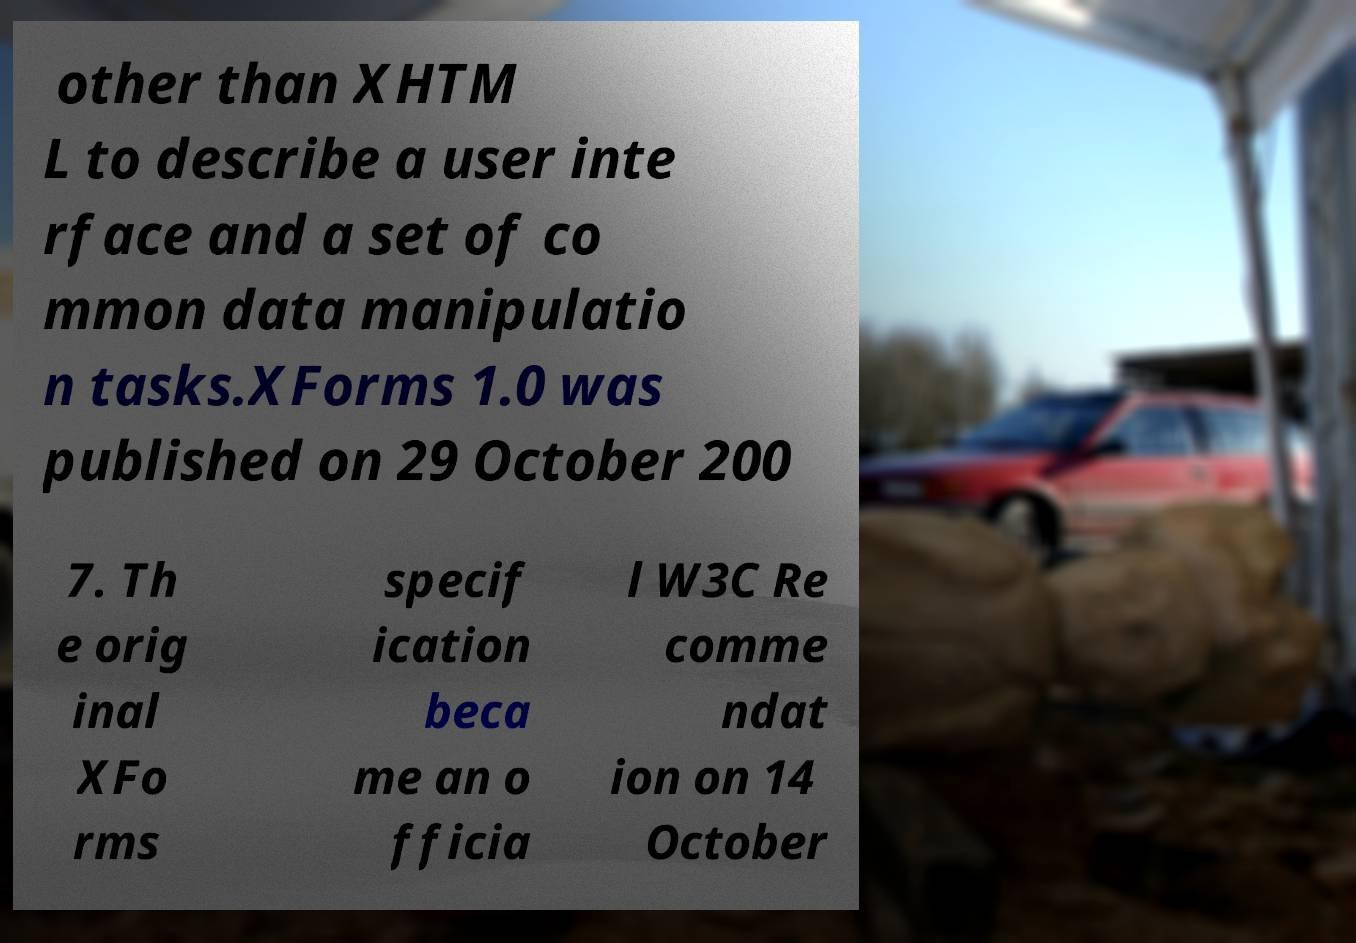Please read and relay the text visible in this image. What does it say? other than XHTM L to describe a user inte rface and a set of co mmon data manipulatio n tasks.XForms 1.0 was published on 29 October 200 7. Th e orig inal XFo rms specif ication beca me an o fficia l W3C Re comme ndat ion on 14 October 